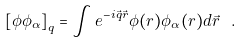<formula> <loc_0><loc_0><loc_500><loc_500>\left [ \phi \phi _ { \alpha } \right ] _ { q } = \int e ^ { - i \vec { q } \vec { r } } \phi ( r ) \phi _ { \alpha } ( r ) d \vec { r } \ .</formula> 